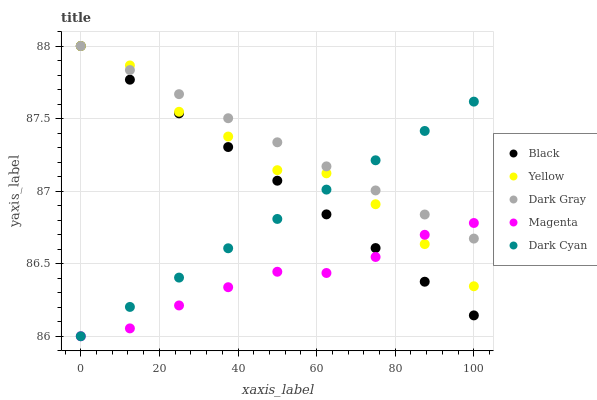Does Magenta have the minimum area under the curve?
Answer yes or no. Yes. Does Dark Gray have the maximum area under the curve?
Answer yes or no. Yes. Does Dark Cyan have the minimum area under the curve?
Answer yes or no. No. Does Dark Cyan have the maximum area under the curve?
Answer yes or no. No. Is Dark Cyan the smoothest?
Answer yes or no. Yes. Is Yellow the roughest?
Answer yes or no. Yes. Is Magenta the smoothest?
Answer yes or no. No. Is Magenta the roughest?
Answer yes or no. No. Does Dark Cyan have the lowest value?
Answer yes or no. Yes. Does Black have the lowest value?
Answer yes or no. No. Does Yellow have the highest value?
Answer yes or no. Yes. Does Dark Cyan have the highest value?
Answer yes or no. No. Does Magenta intersect Black?
Answer yes or no. Yes. Is Magenta less than Black?
Answer yes or no. No. Is Magenta greater than Black?
Answer yes or no. No. 